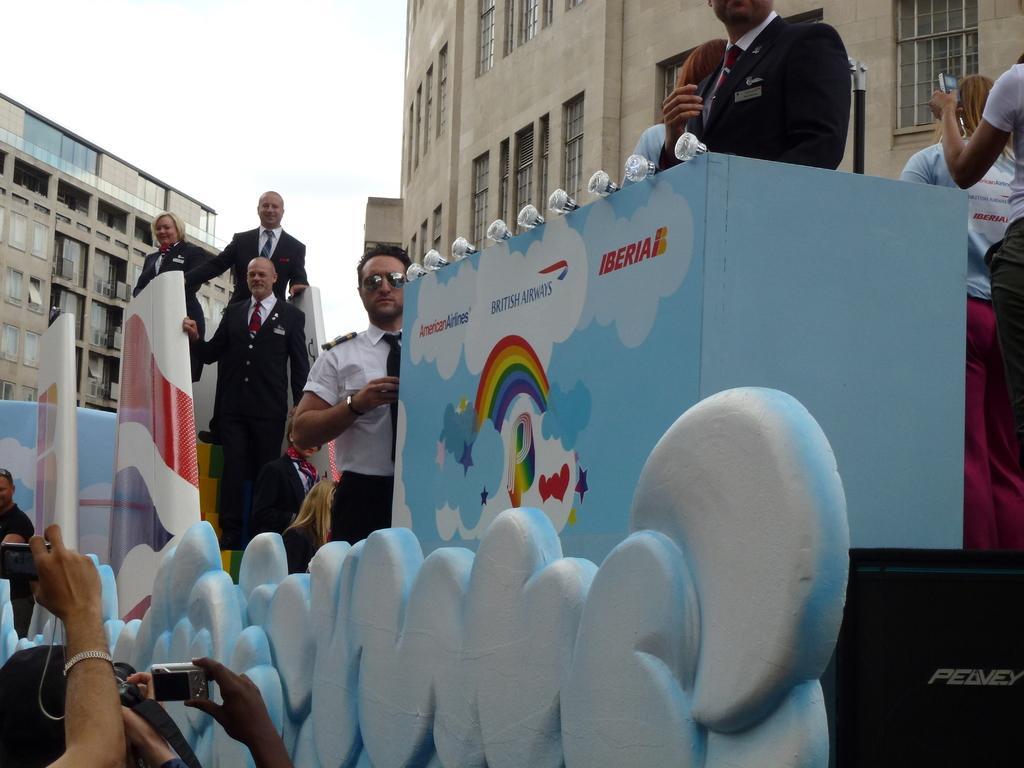Could you give a brief overview of what you see in this image? Here in this picture we can see a group of people standing over a place, as we can see the place is decorated over there and in the middle we can see lights present on it and behind them we can see buildings present over there and in the front we can see people capturing the moment with cameras in their hand over there. 